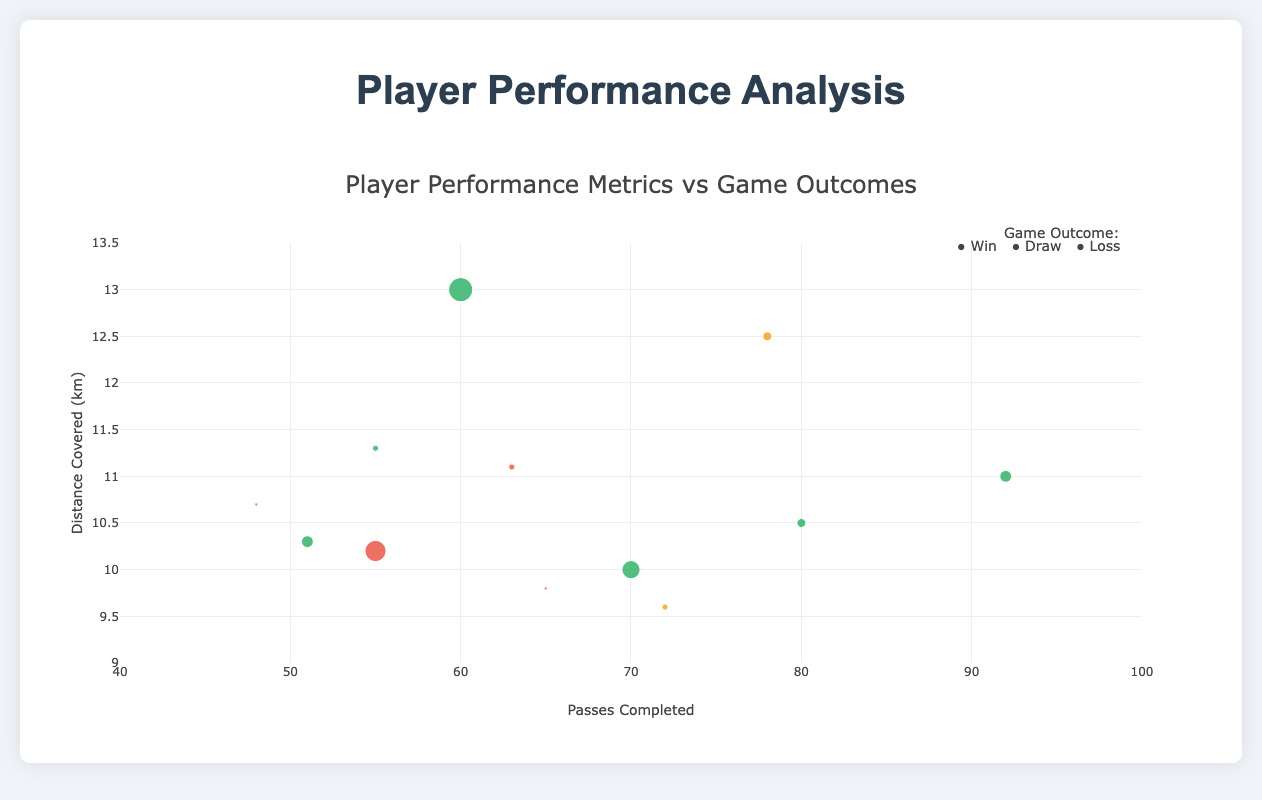How many players' performance data points are displayed in the plot? The plot shows data points for each player, which are represented as markers. Count the number of such markers to find the answer.
Answer: 12 What distinguishes the game outcomes in the plot? Colors of the markers represent different game outcomes: green for wins, red for losses, and orange for draws.
Answer: Different colors Which player has the highest number of passes completed? Observing the x-axis, identify the marker that's farthest to the right. Each marker is labeled with the player's name.
Answer: Kevin De Bruyne Comparing "Lionel Messi" and "Cristiano Ronaldo," who covered more distance? Check the y-axis values for both their markers and compare the heights.
Answer: Cristiano Ronaldo What is the average distance covered by players in games where the team won? Identify all markers colored in green, sum their y-axis values, and divide by the number of green markers.
Answer: 11.08 km Which player made the most tackles in a game ending in a win? Look at the green markers and check the size of each, which corresponds to tackles made. The largest marker indicates the most tackles.
Answer: N'Golo Kante What is the relationship between passes completed and distance covered for players in winning games? Examine the markers in green to see if there's a visible trend, such as positive correlation between x and y values.
Answer: Generally positive correlation Are there any players who had high passes completed but their team didn't win? Look for markers in the x-axis' higher range (above 70 passes) and check their colors.
Answer: Neymar Jr, Luka Modric (didn't win) Which game outcome involved players covering the least distance on average? Identify the average y-axis values for each color group (green for win, red for loss, orange for draw) and find the smallest average.
Answer: Draw What range of passes completed is most common among players? Check where most of the markers are clustered along the x-axis to determine the range.
Answer: 55 - 80 passes 